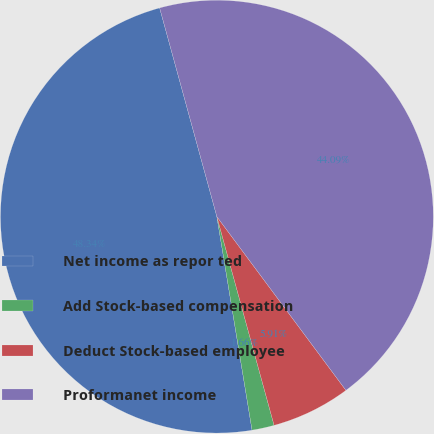<chart> <loc_0><loc_0><loc_500><loc_500><pie_chart><fcel>Net income as repor ted<fcel>Add Stock-based compensation<fcel>Deduct Stock-based employee<fcel>Proformanet income<nl><fcel>48.34%<fcel>1.66%<fcel>5.91%<fcel>44.09%<nl></chart> 